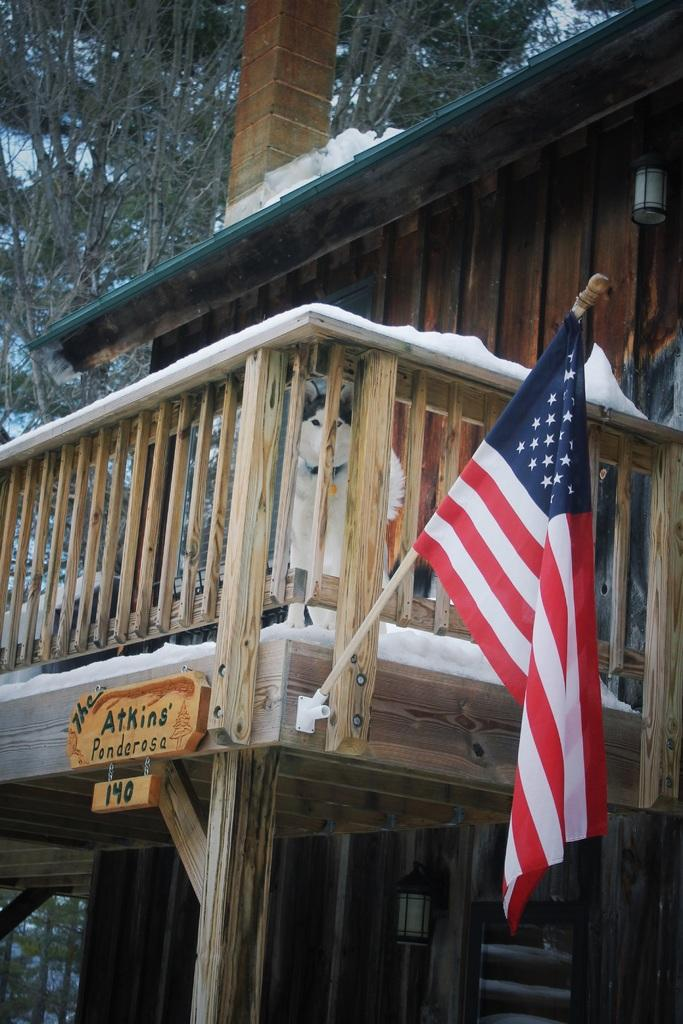What type of animal can be seen in the image? There is an animal in the image, but its specific type cannot be determined from the provided facts. What kind of structure is present in the image? There is a wooden house in the image. What is the weather like in the image? There is snow visible in the image, suggesting a cold or wintery environment. What is the purpose of the wooden fence in the image? The wooden fence in the image could serve as a boundary or barrier. What is attached to the wooden house in the image? There is a name plate in the image, which may indicate the name of the house or its occupants. What other natural elements can be seen in the image? There are trees in the image. What type of punishment is being administered to the animal in the image? There is no indication of punishment in the image; it only shows an animal, a wooden house, a wooden fence, snow, trees, and a name plate. What is the animal using to water the celery in the image? There is no celery or watering activity present in the image. 